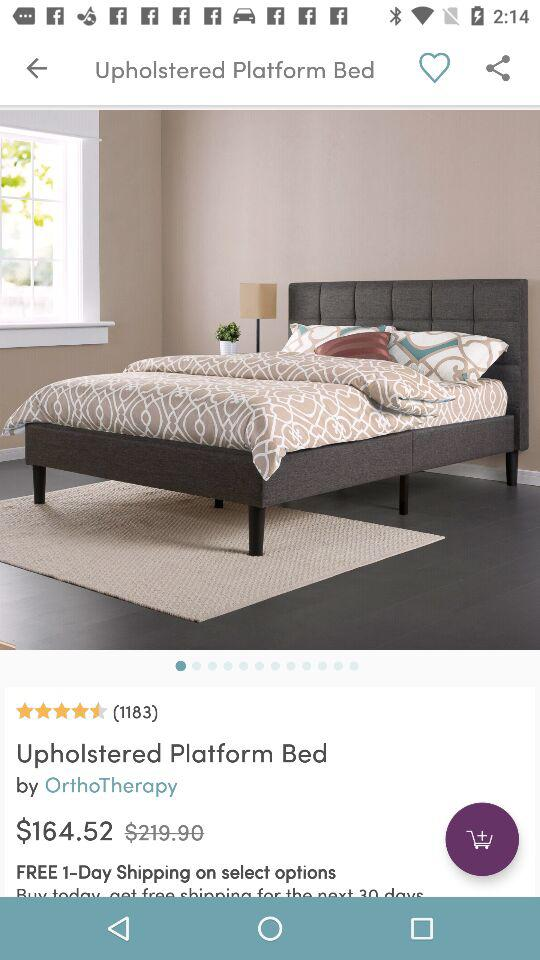What is the currency of price? The currency is the dollar. 